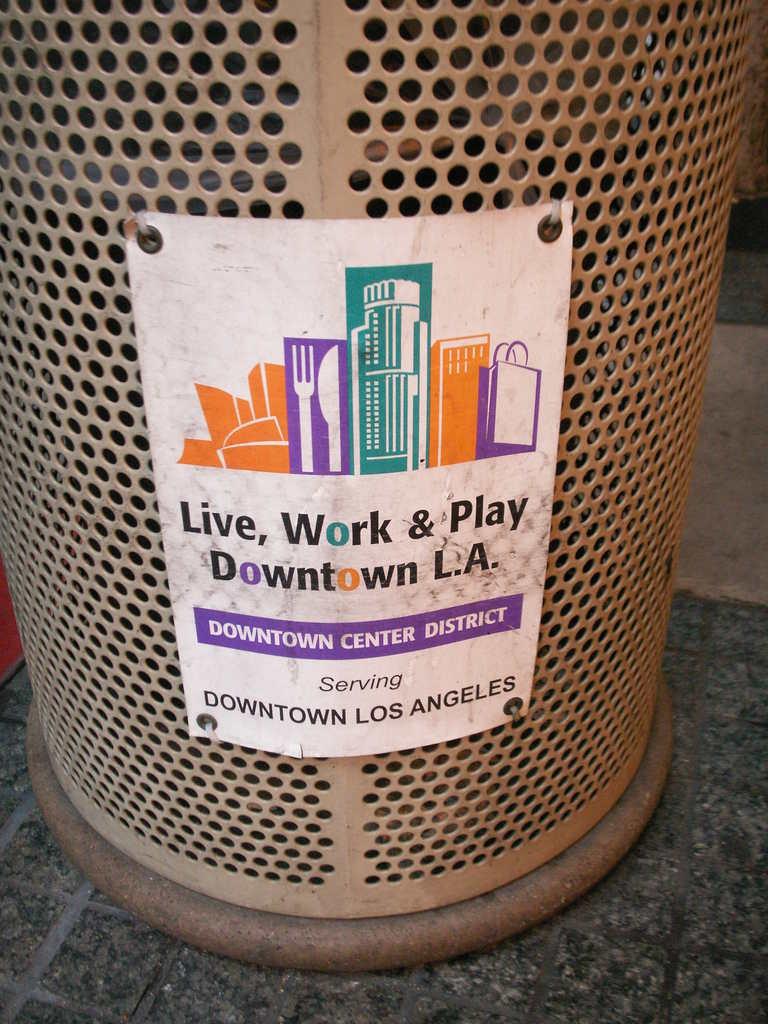What location is on the bin?
Keep it short and to the point. Downtown los angeles. 